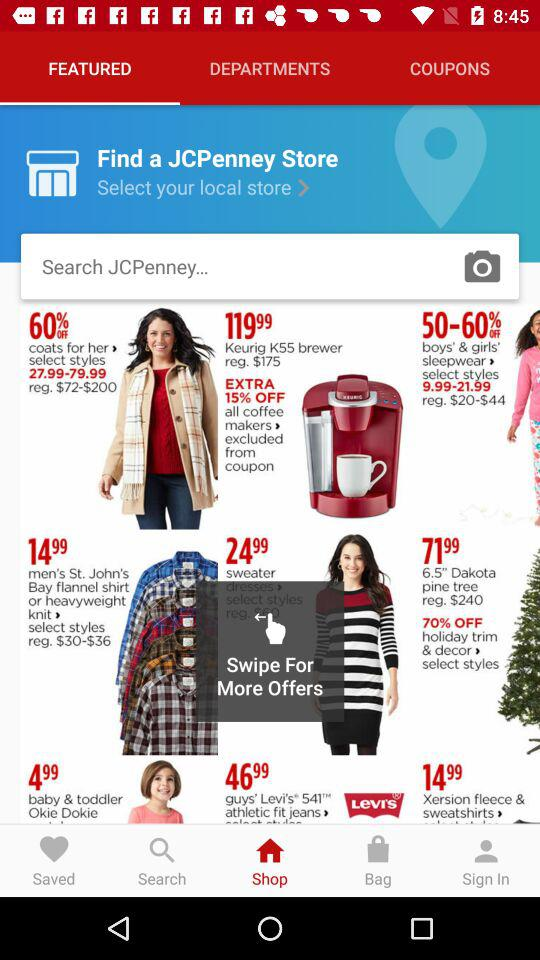What is the price of a Keurig K55 brewer? The price of a Keurig K55 brewer is $175. 